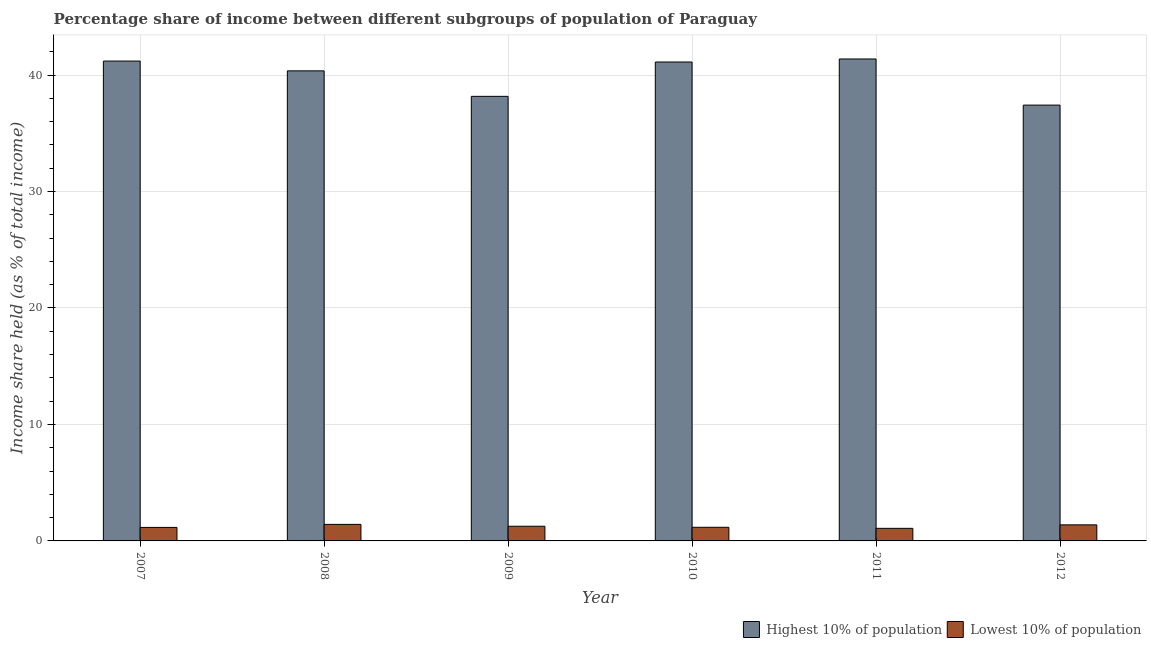Are the number of bars per tick equal to the number of legend labels?
Make the answer very short. Yes. Are the number of bars on each tick of the X-axis equal?
Ensure brevity in your answer.  Yes. How many bars are there on the 6th tick from the left?
Give a very brief answer. 2. What is the income share held by highest 10% of the population in 2009?
Provide a succinct answer. 38.17. Across all years, what is the maximum income share held by lowest 10% of the population?
Your answer should be very brief. 1.42. Across all years, what is the minimum income share held by highest 10% of the population?
Make the answer very short. 37.42. In which year was the income share held by highest 10% of the population maximum?
Give a very brief answer. 2011. What is the total income share held by lowest 10% of the population in the graph?
Offer a terse response. 7.47. What is the difference between the income share held by lowest 10% of the population in 2008 and that in 2012?
Make the answer very short. 0.04. What is the difference between the income share held by highest 10% of the population in 2011 and the income share held by lowest 10% of the population in 2007?
Offer a terse response. 0.18. What is the average income share held by highest 10% of the population per year?
Your response must be concise. 39.94. In the year 2008, what is the difference between the income share held by lowest 10% of the population and income share held by highest 10% of the population?
Offer a very short reply. 0. In how many years, is the income share held by highest 10% of the population greater than 22 %?
Make the answer very short. 6. What is the ratio of the income share held by lowest 10% of the population in 2009 to that in 2011?
Your answer should be very brief. 1.17. Is the difference between the income share held by lowest 10% of the population in 2009 and 2012 greater than the difference between the income share held by highest 10% of the population in 2009 and 2012?
Offer a very short reply. No. What is the difference between the highest and the second highest income share held by highest 10% of the population?
Offer a terse response. 0.18. What is the difference between the highest and the lowest income share held by lowest 10% of the population?
Offer a terse response. 0.34. In how many years, is the income share held by lowest 10% of the population greater than the average income share held by lowest 10% of the population taken over all years?
Your answer should be very brief. 3. What does the 1st bar from the left in 2007 represents?
Make the answer very short. Highest 10% of population. What does the 1st bar from the right in 2012 represents?
Your answer should be very brief. Lowest 10% of population. How many years are there in the graph?
Your answer should be very brief. 6. What is the difference between two consecutive major ticks on the Y-axis?
Provide a short and direct response. 10. Does the graph contain any zero values?
Provide a short and direct response. No. Does the graph contain grids?
Ensure brevity in your answer.  Yes. Where does the legend appear in the graph?
Keep it short and to the point. Bottom right. What is the title of the graph?
Give a very brief answer. Percentage share of income between different subgroups of population of Paraguay. Does "All education staff compensation" appear as one of the legend labels in the graph?
Make the answer very short. No. What is the label or title of the Y-axis?
Provide a succinct answer. Income share held (as % of total income). What is the Income share held (as % of total income) in Highest 10% of population in 2007?
Offer a very short reply. 41.2. What is the Income share held (as % of total income) in Lowest 10% of population in 2007?
Make the answer very short. 1.16. What is the Income share held (as % of total income) in Highest 10% of population in 2008?
Make the answer very short. 40.36. What is the Income share held (as % of total income) in Lowest 10% of population in 2008?
Give a very brief answer. 1.42. What is the Income share held (as % of total income) of Highest 10% of population in 2009?
Provide a short and direct response. 38.17. What is the Income share held (as % of total income) of Lowest 10% of population in 2009?
Offer a very short reply. 1.26. What is the Income share held (as % of total income) in Highest 10% of population in 2010?
Ensure brevity in your answer.  41.12. What is the Income share held (as % of total income) in Lowest 10% of population in 2010?
Your response must be concise. 1.17. What is the Income share held (as % of total income) of Highest 10% of population in 2011?
Ensure brevity in your answer.  41.38. What is the Income share held (as % of total income) of Lowest 10% of population in 2011?
Your answer should be very brief. 1.08. What is the Income share held (as % of total income) in Highest 10% of population in 2012?
Provide a succinct answer. 37.42. What is the Income share held (as % of total income) of Lowest 10% of population in 2012?
Your answer should be compact. 1.38. Across all years, what is the maximum Income share held (as % of total income) in Highest 10% of population?
Provide a short and direct response. 41.38. Across all years, what is the maximum Income share held (as % of total income) of Lowest 10% of population?
Make the answer very short. 1.42. Across all years, what is the minimum Income share held (as % of total income) in Highest 10% of population?
Provide a short and direct response. 37.42. What is the total Income share held (as % of total income) of Highest 10% of population in the graph?
Your response must be concise. 239.65. What is the total Income share held (as % of total income) of Lowest 10% of population in the graph?
Ensure brevity in your answer.  7.47. What is the difference between the Income share held (as % of total income) in Highest 10% of population in 2007 and that in 2008?
Your answer should be very brief. 0.84. What is the difference between the Income share held (as % of total income) in Lowest 10% of population in 2007 and that in 2008?
Your answer should be very brief. -0.26. What is the difference between the Income share held (as % of total income) of Highest 10% of population in 2007 and that in 2009?
Offer a very short reply. 3.03. What is the difference between the Income share held (as % of total income) in Lowest 10% of population in 2007 and that in 2009?
Make the answer very short. -0.1. What is the difference between the Income share held (as % of total income) in Lowest 10% of population in 2007 and that in 2010?
Offer a terse response. -0.01. What is the difference between the Income share held (as % of total income) of Highest 10% of population in 2007 and that in 2011?
Provide a succinct answer. -0.18. What is the difference between the Income share held (as % of total income) of Highest 10% of population in 2007 and that in 2012?
Make the answer very short. 3.78. What is the difference between the Income share held (as % of total income) in Lowest 10% of population in 2007 and that in 2012?
Your response must be concise. -0.22. What is the difference between the Income share held (as % of total income) of Highest 10% of population in 2008 and that in 2009?
Keep it short and to the point. 2.19. What is the difference between the Income share held (as % of total income) of Lowest 10% of population in 2008 and that in 2009?
Keep it short and to the point. 0.16. What is the difference between the Income share held (as % of total income) of Highest 10% of population in 2008 and that in 2010?
Make the answer very short. -0.76. What is the difference between the Income share held (as % of total income) in Lowest 10% of population in 2008 and that in 2010?
Give a very brief answer. 0.25. What is the difference between the Income share held (as % of total income) in Highest 10% of population in 2008 and that in 2011?
Keep it short and to the point. -1.02. What is the difference between the Income share held (as % of total income) of Lowest 10% of population in 2008 and that in 2011?
Your answer should be very brief. 0.34. What is the difference between the Income share held (as % of total income) in Highest 10% of population in 2008 and that in 2012?
Offer a terse response. 2.94. What is the difference between the Income share held (as % of total income) of Lowest 10% of population in 2008 and that in 2012?
Provide a short and direct response. 0.04. What is the difference between the Income share held (as % of total income) of Highest 10% of population in 2009 and that in 2010?
Offer a very short reply. -2.95. What is the difference between the Income share held (as % of total income) in Lowest 10% of population in 2009 and that in 2010?
Offer a terse response. 0.09. What is the difference between the Income share held (as % of total income) of Highest 10% of population in 2009 and that in 2011?
Your answer should be very brief. -3.21. What is the difference between the Income share held (as % of total income) in Lowest 10% of population in 2009 and that in 2011?
Offer a very short reply. 0.18. What is the difference between the Income share held (as % of total income) of Highest 10% of population in 2009 and that in 2012?
Give a very brief answer. 0.75. What is the difference between the Income share held (as % of total income) in Lowest 10% of population in 2009 and that in 2012?
Keep it short and to the point. -0.12. What is the difference between the Income share held (as % of total income) in Highest 10% of population in 2010 and that in 2011?
Provide a short and direct response. -0.26. What is the difference between the Income share held (as % of total income) in Lowest 10% of population in 2010 and that in 2011?
Ensure brevity in your answer.  0.09. What is the difference between the Income share held (as % of total income) of Highest 10% of population in 2010 and that in 2012?
Offer a very short reply. 3.7. What is the difference between the Income share held (as % of total income) in Lowest 10% of population in 2010 and that in 2012?
Your response must be concise. -0.21. What is the difference between the Income share held (as % of total income) in Highest 10% of population in 2011 and that in 2012?
Your answer should be compact. 3.96. What is the difference between the Income share held (as % of total income) of Highest 10% of population in 2007 and the Income share held (as % of total income) of Lowest 10% of population in 2008?
Ensure brevity in your answer.  39.78. What is the difference between the Income share held (as % of total income) in Highest 10% of population in 2007 and the Income share held (as % of total income) in Lowest 10% of population in 2009?
Offer a terse response. 39.94. What is the difference between the Income share held (as % of total income) in Highest 10% of population in 2007 and the Income share held (as % of total income) in Lowest 10% of population in 2010?
Your answer should be compact. 40.03. What is the difference between the Income share held (as % of total income) of Highest 10% of population in 2007 and the Income share held (as % of total income) of Lowest 10% of population in 2011?
Your response must be concise. 40.12. What is the difference between the Income share held (as % of total income) in Highest 10% of population in 2007 and the Income share held (as % of total income) in Lowest 10% of population in 2012?
Your response must be concise. 39.82. What is the difference between the Income share held (as % of total income) in Highest 10% of population in 2008 and the Income share held (as % of total income) in Lowest 10% of population in 2009?
Your answer should be very brief. 39.1. What is the difference between the Income share held (as % of total income) in Highest 10% of population in 2008 and the Income share held (as % of total income) in Lowest 10% of population in 2010?
Your response must be concise. 39.19. What is the difference between the Income share held (as % of total income) in Highest 10% of population in 2008 and the Income share held (as % of total income) in Lowest 10% of population in 2011?
Make the answer very short. 39.28. What is the difference between the Income share held (as % of total income) of Highest 10% of population in 2008 and the Income share held (as % of total income) of Lowest 10% of population in 2012?
Your response must be concise. 38.98. What is the difference between the Income share held (as % of total income) in Highest 10% of population in 2009 and the Income share held (as % of total income) in Lowest 10% of population in 2011?
Provide a succinct answer. 37.09. What is the difference between the Income share held (as % of total income) of Highest 10% of population in 2009 and the Income share held (as % of total income) of Lowest 10% of population in 2012?
Offer a terse response. 36.79. What is the difference between the Income share held (as % of total income) of Highest 10% of population in 2010 and the Income share held (as % of total income) of Lowest 10% of population in 2011?
Ensure brevity in your answer.  40.04. What is the difference between the Income share held (as % of total income) in Highest 10% of population in 2010 and the Income share held (as % of total income) in Lowest 10% of population in 2012?
Ensure brevity in your answer.  39.74. What is the average Income share held (as % of total income) of Highest 10% of population per year?
Your answer should be very brief. 39.94. What is the average Income share held (as % of total income) of Lowest 10% of population per year?
Offer a very short reply. 1.25. In the year 2007, what is the difference between the Income share held (as % of total income) of Highest 10% of population and Income share held (as % of total income) of Lowest 10% of population?
Keep it short and to the point. 40.04. In the year 2008, what is the difference between the Income share held (as % of total income) of Highest 10% of population and Income share held (as % of total income) of Lowest 10% of population?
Offer a terse response. 38.94. In the year 2009, what is the difference between the Income share held (as % of total income) of Highest 10% of population and Income share held (as % of total income) of Lowest 10% of population?
Your answer should be compact. 36.91. In the year 2010, what is the difference between the Income share held (as % of total income) in Highest 10% of population and Income share held (as % of total income) in Lowest 10% of population?
Offer a terse response. 39.95. In the year 2011, what is the difference between the Income share held (as % of total income) in Highest 10% of population and Income share held (as % of total income) in Lowest 10% of population?
Offer a very short reply. 40.3. In the year 2012, what is the difference between the Income share held (as % of total income) of Highest 10% of population and Income share held (as % of total income) of Lowest 10% of population?
Provide a short and direct response. 36.04. What is the ratio of the Income share held (as % of total income) in Highest 10% of population in 2007 to that in 2008?
Your response must be concise. 1.02. What is the ratio of the Income share held (as % of total income) in Lowest 10% of population in 2007 to that in 2008?
Your answer should be very brief. 0.82. What is the ratio of the Income share held (as % of total income) of Highest 10% of population in 2007 to that in 2009?
Ensure brevity in your answer.  1.08. What is the ratio of the Income share held (as % of total income) of Lowest 10% of population in 2007 to that in 2009?
Provide a short and direct response. 0.92. What is the ratio of the Income share held (as % of total income) of Highest 10% of population in 2007 to that in 2010?
Provide a succinct answer. 1. What is the ratio of the Income share held (as % of total income) in Highest 10% of population in 2007 to that in 2011?
Your answer should be very brief. 1. What is the ratio of the Income share held (as % of total income) of Lowest 10% of population in 2007 to that in 2011?
Offer a terse response. 1.07. What is the ratio of the Income share held (as % of total income) in Highest 10% of population in 2007 to that in 2012?
Provide a short and direct response. 1.1. What is the ratio of the Income share held (as % of total income) in Lowest 10% of population in 2007 to that in 2012?
Keep it short and to the point. 0.84. What is the ratio of the Income share held (as % of total income) of Highest 10% of population in 2008 to that in 2009?
Your answer should be compact. 1.06. What is the ratio of the Income share held (as % of total income) in Lowest 10% of population in 2008 to that in 2009?
Keep it short and to the point. 1.13. What is the ratio of the Income share held (as % of total income) of Highest 10% of population in 2008 to that in 2010?
Your answer should be compact. 0.98. What is the ratio of the Income share held (as % of total income) in Lowest 10% of population in 2008 to that in 2010?
Keep it short and to the point. 1.21. What is the ratio of the Income share held (as % of total income) in Highest 10% of population in 2008 to that in 2011?
Offer a terse response. 0.98. What is the ratio of the Income share held (as % of total income) of Lowest 10% of population in 2008 to that in 2011?
Provide a short and direct response. 1.31. What is the ratio of the Income share held (as % of total income) in Highest 10% of population in 2008 to that in 2012?
Make the answer very short. 1.08. What is the ratio of the Income share held (as % of total income) in Highest 10% of population in 2009 to that in 2010?
Offer a very short reply. 0.93. What is the ratio of the Income share held (as % of total income) of Highest 10% of population in 2009 to that in 2011?
Offer a terse response. 0.92. What is the ratio of the Income share held (as % of total income) of Lowest 10% of population in 2009 to that in 2011?
Your answer should be very brief. 1.17. What is the ratio of the Income share held (as % of total income) in Highest 10% of population in 2010 to that in 2011?
Keep it short and to the point. 0.99. What is the ratio of the Income share held (as % of total income) in Lowest 10% of population in 2010 to that in 2011?
Offer a terse response. 1.08. What is the ratio of the Income share held (as % of total income) of Highest 10% of population in 2010 to that in 2012?
Your answer should be very brief. 1.1. What is the ratio of the Income share held (as % of total income) of Lowest 10% of population in 2010 to that in 2012?
Your answer should be very brief. 0.85. What is the ratio of the Income share held (as % of total income) in Highest 10% of population in 2011 to that in 2012?
Provide a short and direct response. 1.11. What is the ratio of the Income share held (as % of total income) in Lowest 10% of population in 2011 to that in 2012?
Your answer should be compact. 0.78. What is the difference between the highest and the second highest Income share held (as % of total income) of Highest 10% of population?
Give a very brief answer. 0.18. What is the difference between the highest and the lowest Income share held (as % of total income) in Highest 10% of population?
Your answer should be compact. 3.96. What is the difference between the highest and the lowest Income share held (as % of total income) in Lowest 10% of population?
Make the answer very short. 0.34. 